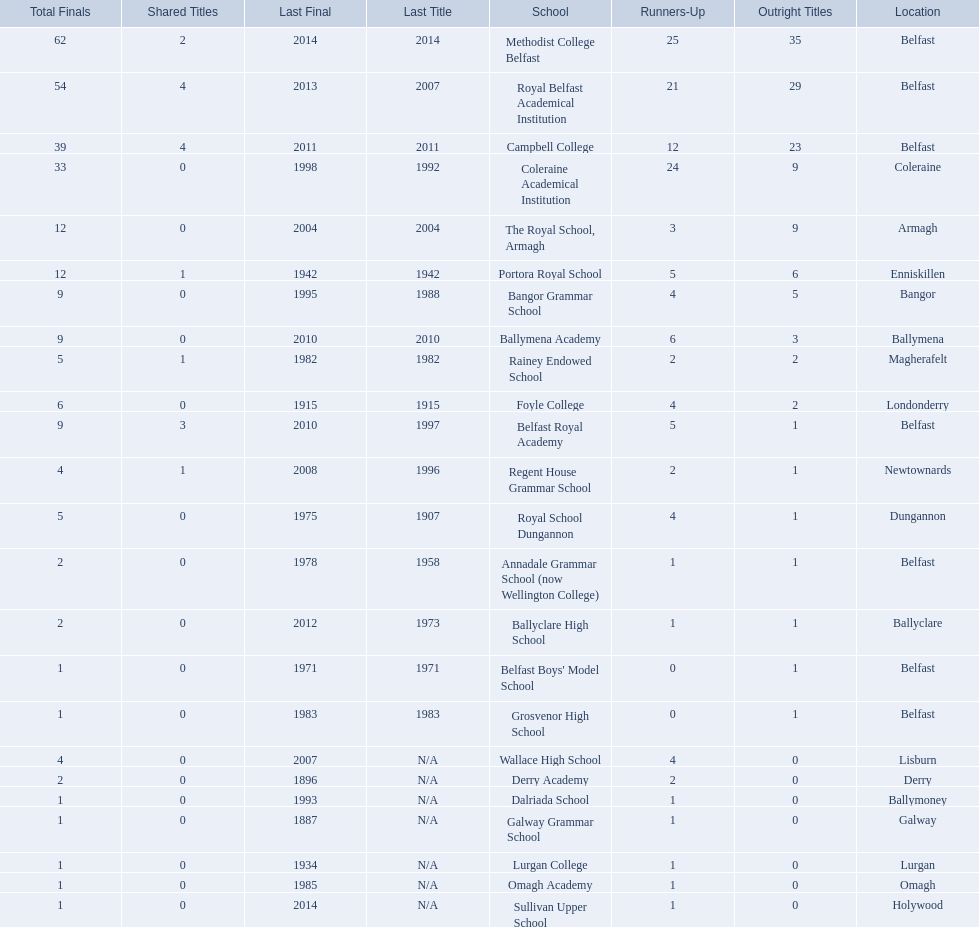Which colleges participated in the ulster's schools' cup? Methodist College Belfast, Royal Belfast Academical Institution, Campbell College, Coleraine Academical Institution, The Royal School, Armagh, Portora Royal School, Bangor Grammar School, Ballymena Academy, Rainey Endowed School, Foyle College, Belfast Royal Academy, Regent House Grammar School, Royal School Dungannon, Annadale Grammar School (now Wellington College), Ballyclare High School, Belfast Boys' Model School, Grosvenor High School, Wallace High School, Derry Academy, Dalriada School, Galway Grammar School, Lurgan College, Omagh Academy, Sullivan Upper School. Of these, which are from belfast? Methodist College Belfast, Royal Belfast Academical Institution, Campbell College, Belfast Royal Academy, Annadale Grammar School (now Wellington College), Belfast Boys' Model School, Grosvenor High School. Of these, which have more than 20 outright titles? Methodist College Belfast, Royal Belfast Academical Institution, Campbell College. Which of these have the fewest runners-up? Campbell College. 